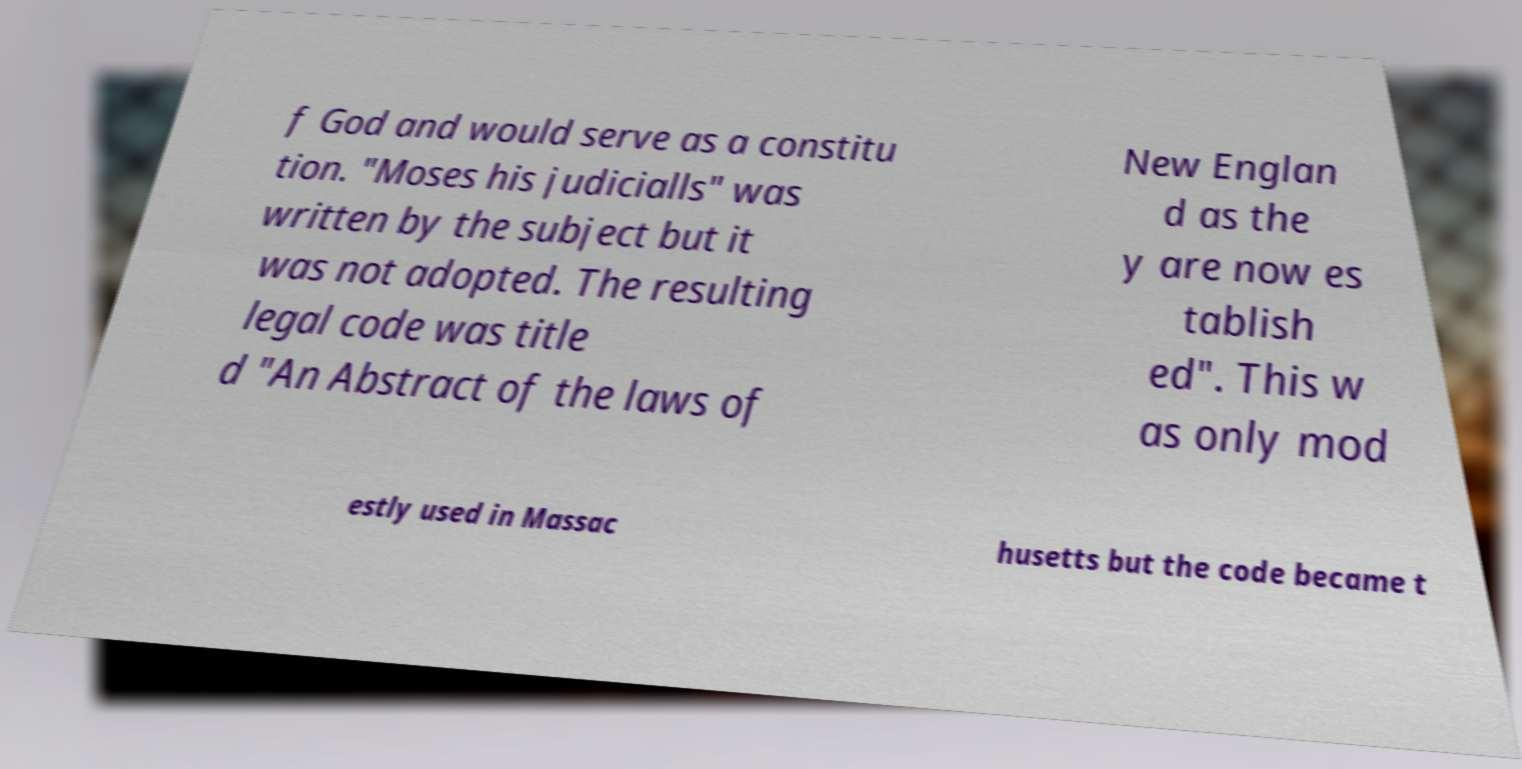For documentation purposes, I need the text within this image transcribed. Could you provide that? f God and would serve as a constitu tion. "Moses his judicialls" was written by the subject but it was not adopted. The resulting legal code was title d "An Abstract of the laws of New Englan d as the y are now es tablish ed". This w as only mod estly used in Massac husetts but the code became t 